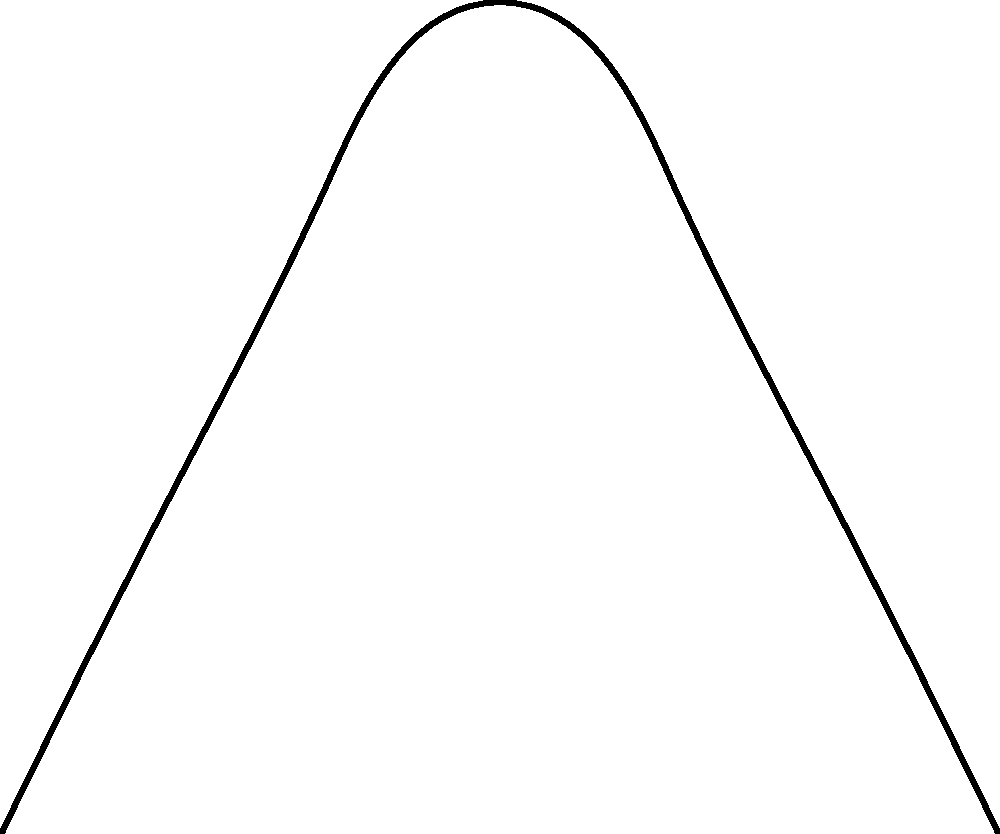In a triple axel jump, a figure skater experiences two main forces: $\vec{F_1}$ (blue) and $\vec{F_2}$ (red), both at an angle $\theta$ from the vertical. If $\|\vec{F_1}\| = 500$ N, $\|\vec{F_2}\| = 400$ N, and $\theta = 30°$, calculate the magnitude of the resultant force $\vec{F_R}$ (green) acting on the skater during the jump. To solve this problem, we'll follow these steps:

1) First, we need to break down each force into its vertical and horizontal components:

   $F_{1x} = \|\vec{F_1}\| \sin\theta = 500 \sin 30° = 250$ N
   $F_{1y} = \|\vec{F_1}\| \cos\theta = 500 \cos 30° = 433.01$ N
   $F_{2x} = \|\vec{F_2}\| \sin\theta = 400 \sin 30° = 200$ N
   $F_{2y} = \|\vec{F_2}\| \cos\theta = 400 \cos 30° = 346.41$ N

2) Now, we can calculate the total horizontal and vertical components of the resultant force:

   $F_{Rx} = F_{1x} + F_{2x} = 250 + 200 = 450$ N
   $F_{Ry} = F_{1y} + F_{2y} = 433.01 + 346.41 = 779.42$ N

3) The magnitude of the resultant force can be calculated using the Pythagorean theorem:

   $\|\vec{F_R}\| = \sqrt{F_{Rx}^2 + F_{Ry}^2}$

4) Substituting the values:

   $\|\vec{F_R}\| = \sqrt{450^2 + 779.42^2}$

5) Calculating the final result:

   $\|\vec{F_R}\| = \sqrt{202500 + 607495.61} = \sqrt{809995.61} = 900$ N (rounded to the nearest whole number)
Answer: 900 N 